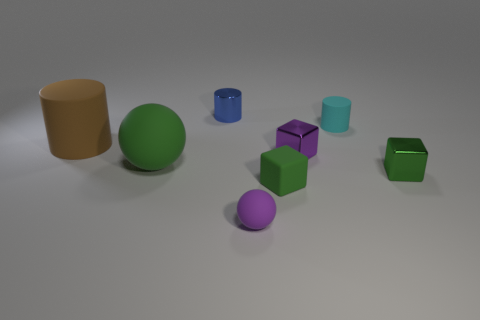Subtract all rubber cubes. How many cubes are left? 2 Subtract all yellow balls. How many green cubes are left? 2 Add 2 small green matte cylinders. How many objects exist? 10 Subtract all green cylinders. Subtract all brown spheres. How many cylinders are left? 3 Subtract all spheres. How many objects are left? 6 Add 5 tiny rubber cubes. How many tiny rubber cubes exist? 6 Subtract 1 green spheres. How many objects are left? 7 Subtract all large yellow metal cylinders. Subtract all brown objects. How many objects are left? 7 Add 8 big things. How many big things are left? 10 